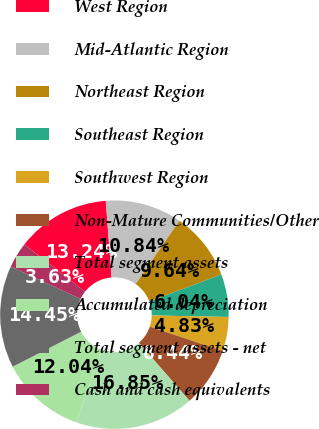Convert chart to OTSL. <chart><loc_0><loc_0><loc_500><loc_500><pie_chart><fcel>West Region<fcel>Mid-Atlantic Region<fcel>Northeast Region<fcel>Southeast Region<fcel>Southwest Region<fcel>Non-Mature Communities/Other<fcel>Total segment assets<fcel>Accumulated depreciation<fcel>Total segment assets - net<fcel>Cash and cash equivalents<nl><fcel>13.24%<fcel>10.84%<fcel>9.64%<fcel>6.04%<fcel>4.83%<fcel>8.44%<fcel>16.85%<fcel>12.04%<fcel>14.45%<fcel>3.63%<nl></chart> 